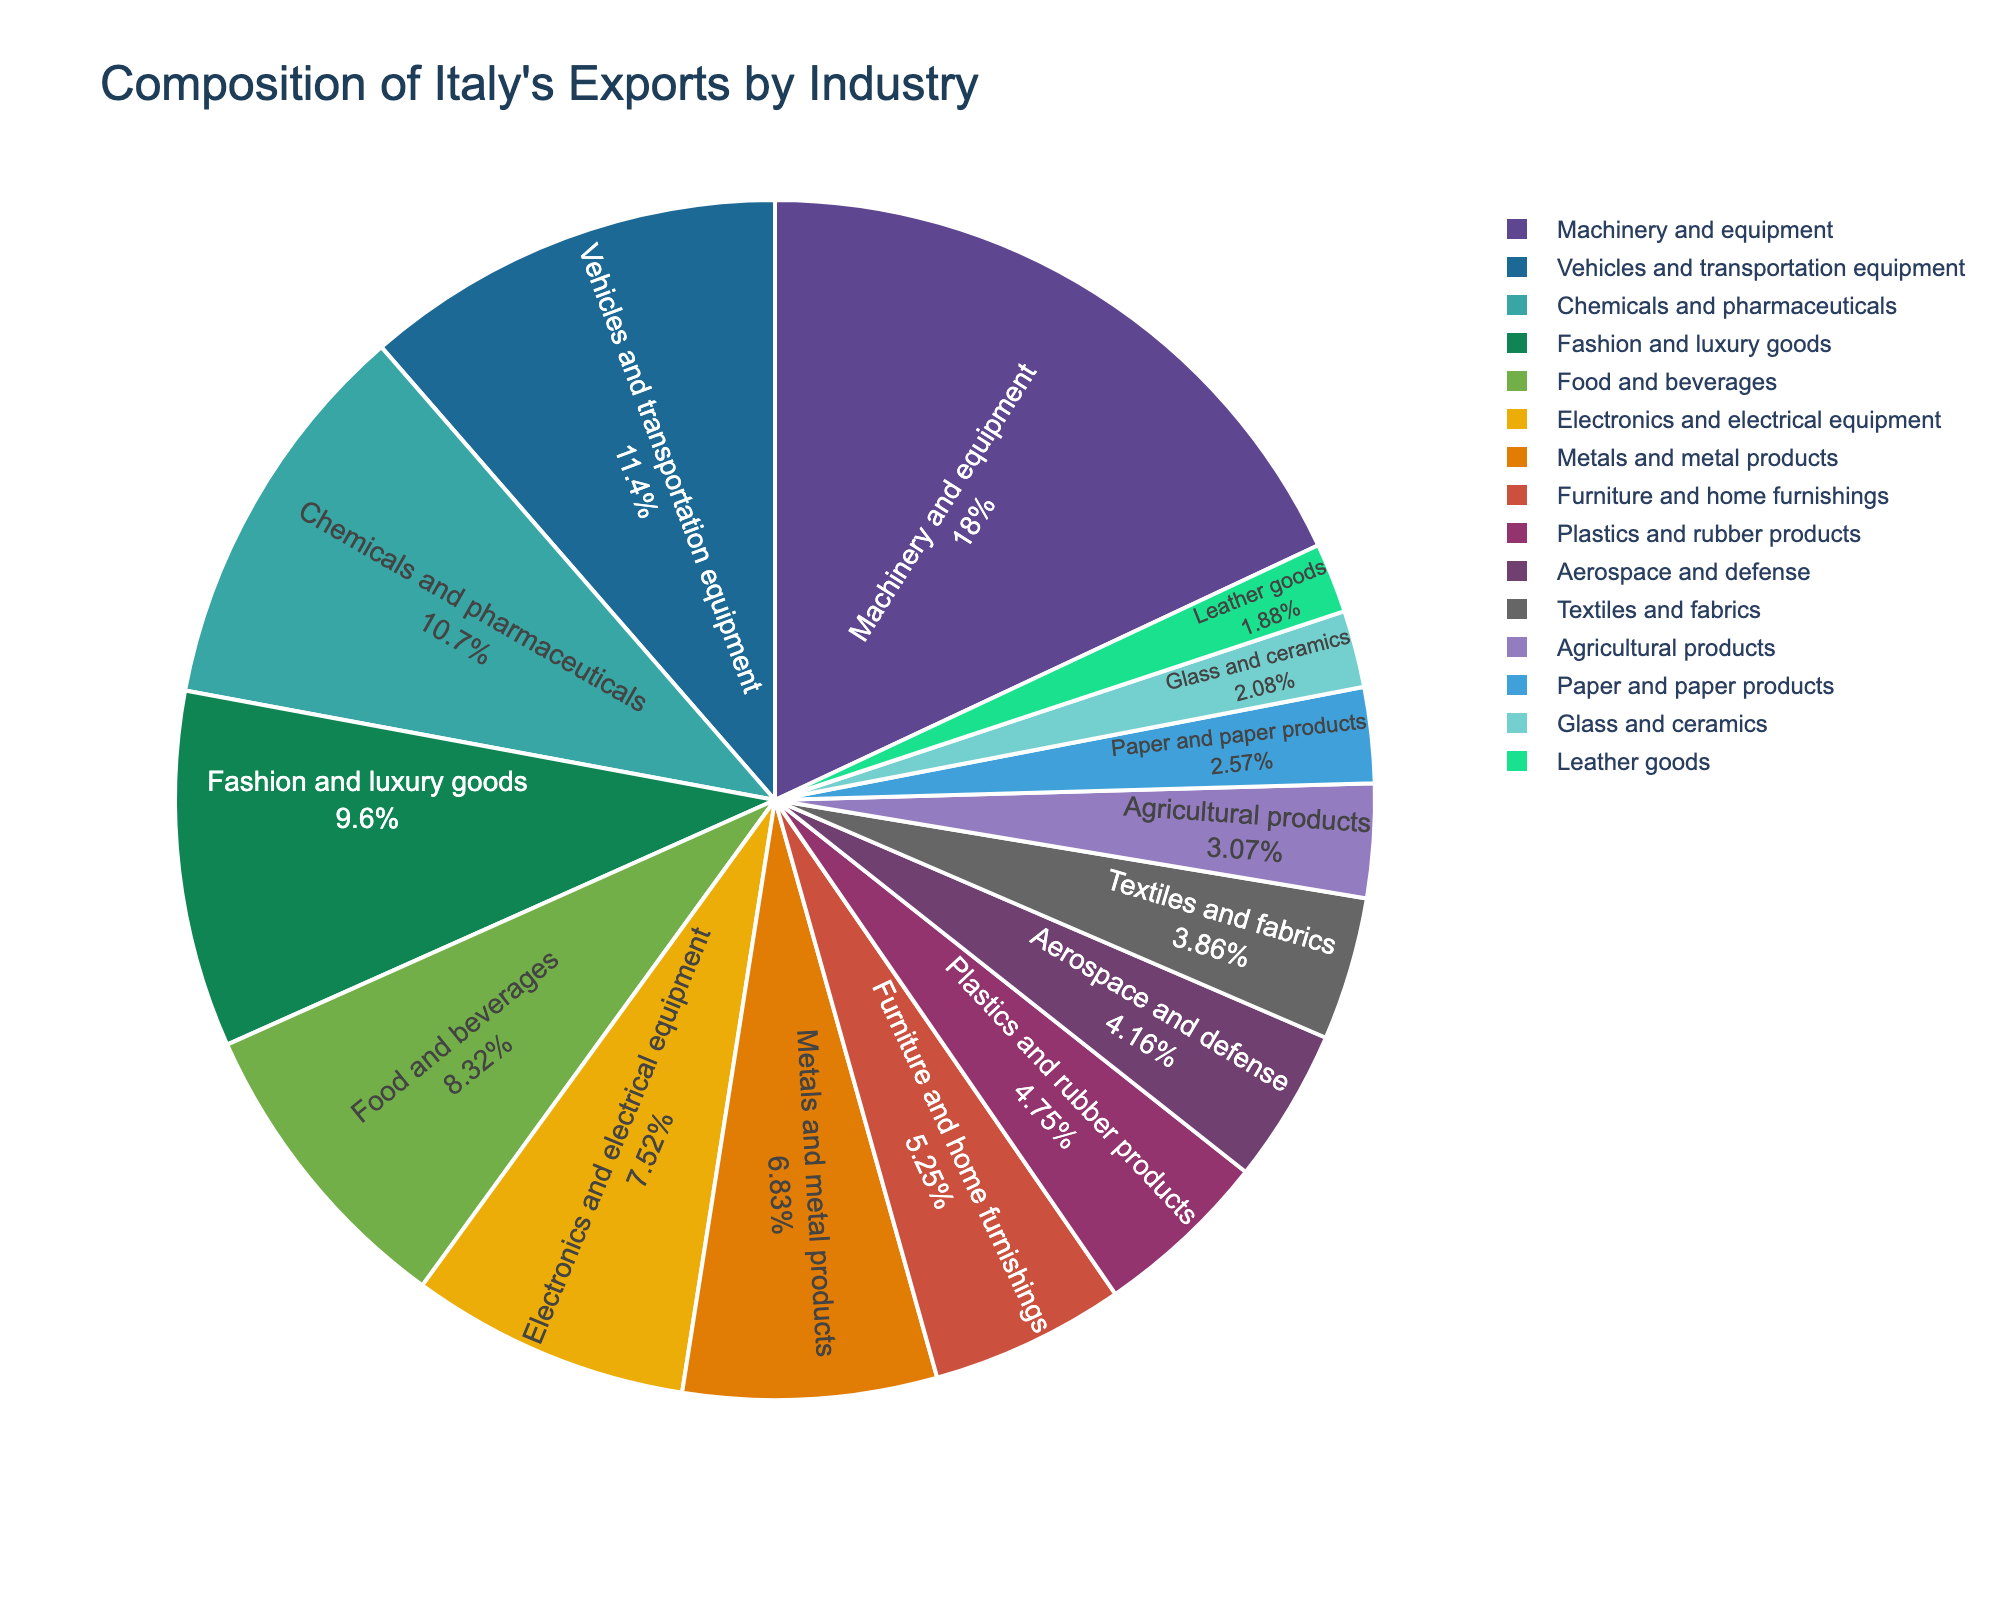Which industry contributes the largest percentage to Italy's exports? The pie chart shows the percentage of each industry. The largest segment is "Machinery and equipment" with 18.2%.
Answer: Machinery and equipment What industries together make up more than 30% of Italy's exports? Adding the two largest segments, Machinery and equipment (18.2%) and Vehicles and transportation equipment (11.5%), gives 29.7%. Adding the next largest, Chemicals and pharmaceuticals (10.8%), totals 40.5%. Machinery and equipment and Vehicles and transportation equipment make up more than 30%.
Answer: Machinery and equipment, Vehicles and transportation equipment Which industry has a larger share of Italy's exports, Fashion and luxury goods or Food and beverages? Fashion and luxury goods contributes 9.7%, while Food and beverages contributes 8.4% according to the pie chart. Therefore, Fashion and luxury goods has a larger share.
Answer: Fashion and luxury goods What is the difference in export percentage between Electronics and electrical equipment and Metals and metal products? Electronics and electrical equipment has a percentage of 7.6%, and Metals and metal products has 6.9%. The difference is calculated as 7.6% - 6.9% = 0.7%.
Answer: 0.7% Which industry contributes just slightly less than 5% to Italy's exports? The industry closest to 5% is Plastics and rubber products with 4.8%, as shown in the pie chart.
Answer: Plastics and rubber products How much more do Chemicals and pharmaceuticals contribute to Italy's exports than Textiles and fabrics? Chemicals and pharmaceuticals contribute 10.8%, whereas Textiles and fabrics contribute 3.9%. The difference is 10.8% - 3.9% = 6.9%.
Answer: 6.9% Is the contribution of Aerospace and defense higher or lower than that of Agricultural products? Aerospace and defense contributes 4.2%, while Agricultural products contributes 3.1%. Thus, Aerospace and defense has a higher contribution.
Answer: Higher Which industry has the smallest share in Italy's exports? The pie chart shows that Leather goods has the smallest share of 1.9%.
Answer: Leather goods 